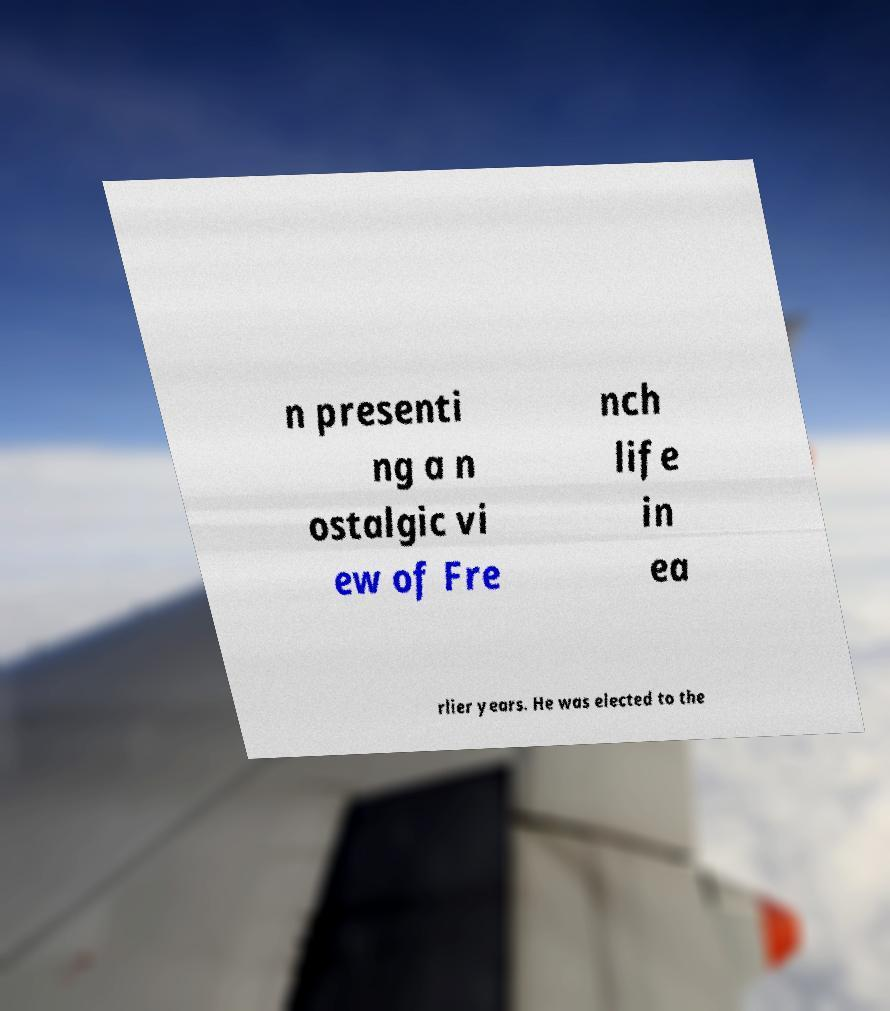Please identify and transcribe the text found in this image. n presenti ng a n ostalgic vi ew of Fre nch life in ea rlier years. He was elected to the 